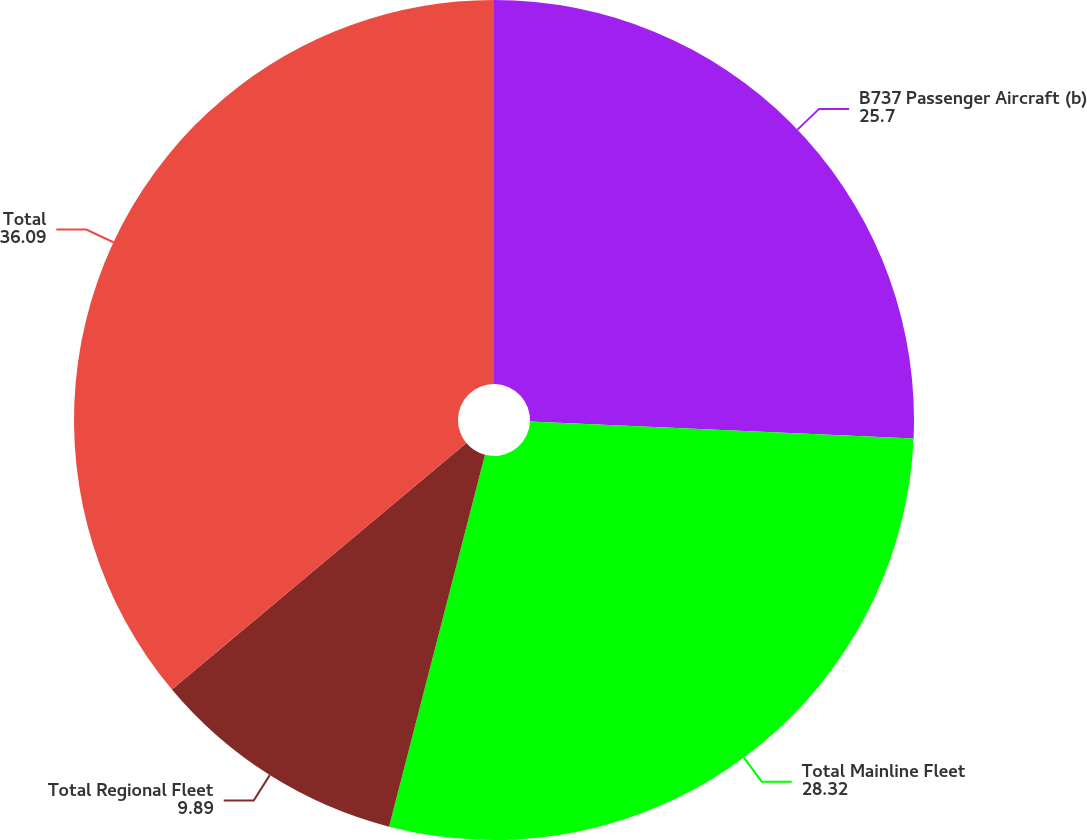Convert chart to OTSL. <chart><loc_0><loc_0><loc_500><loc_500><pie_chart><fcel>B737 Passenger Aircraft (b)<fcel>Total Mainline Fleet<fcel>Total Regional Fleet<fcel>Total<nl><fcel>25.7%<fcel>28.32%<fcel>9.89%<fcel>36.09%<nl></chart> 